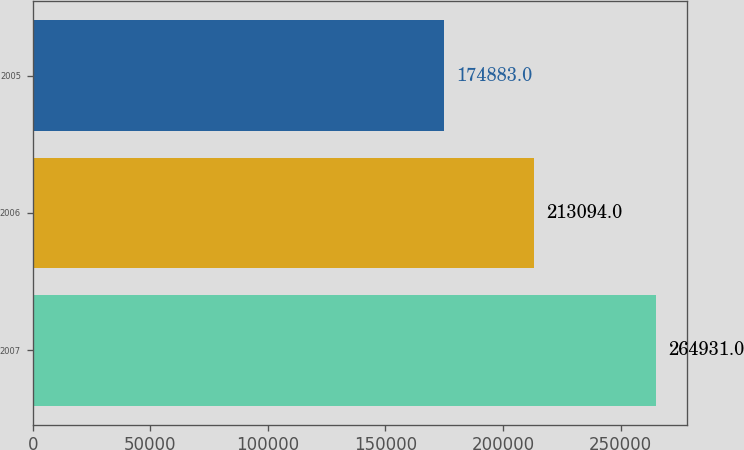<chart> <loc_0><loc_0><loc_500><loc_500><bar_chart><fcel>2007<fcel>2006<fcel>2005<nl><fcel>264931<fcel>213094<fcel>174883<nl></chart> 